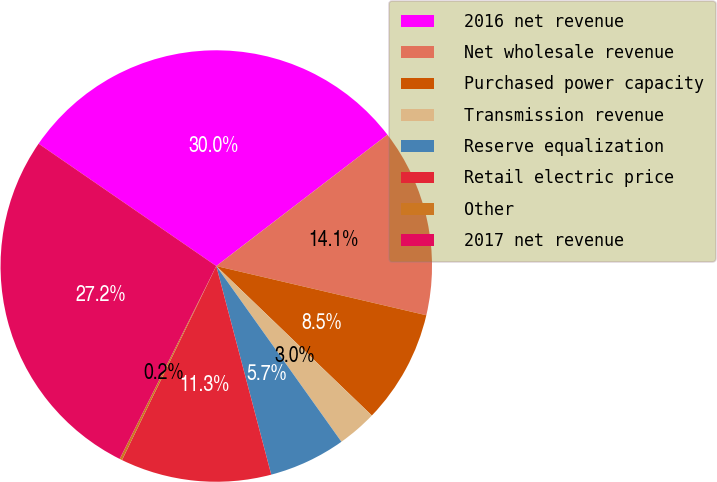<chart> <loc_0><loc_0><loc_500><loc_500><pie_chart><fcel>2016 net revenue<fcel>Net wholesale revenue<fcel>Purchased power capacity<fcel>Transmission revenue<fcel>Reserve equalization<fcel>Retail electric price<fcel>Other<fcel>2017 net revenue<nl><fcel>29.99%<fcel>14.08%<fcel>8.52%<fcel>2.97%<fcel>5.75%<fcel>11.3%<fcel>0.19%<fcel>27.21%<nl></chart> 